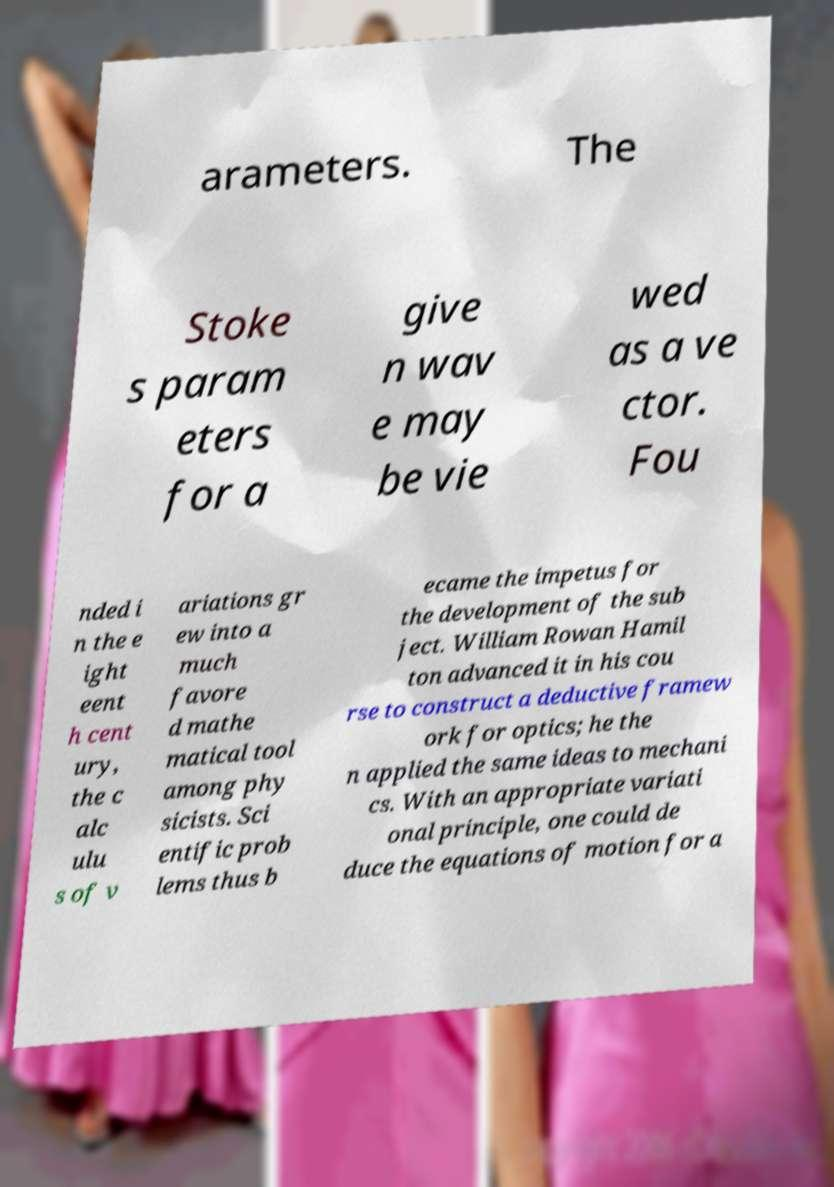Can you read and provide the text displayed in the image?This photo seems to have some interesting text. Can you extract and type it out for me? arameters. The Stoke s param eters for a give n wav e may be vie wed as a ve ctor. Fou nded i n the e ight eent h cent ury, the c alc ulu s of v ariations gr ew into a much favore d mathe matical tool among phy sicists. Sci entific prob lems thus b ecame the impetus for the development of the sub ject. William Rowan Hamil ton advanced it in his cou rse to construct a deductive framew ork for optics; he the n applied the same ideas to mechani cs. With an appropriate variati onal principle, one could de duce the equations of motion for a 